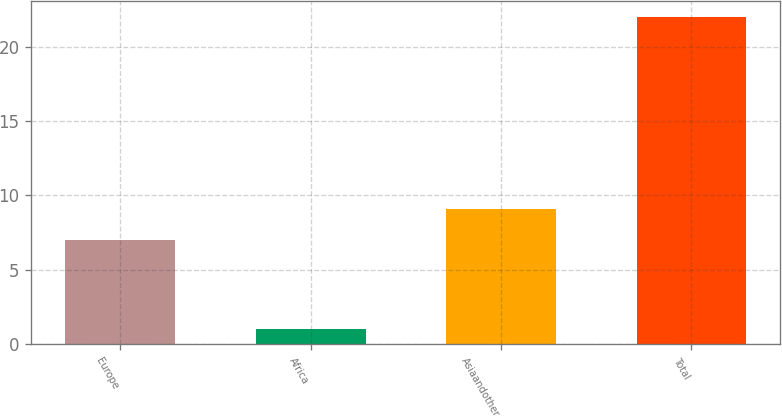<chart> <loc_0><loc_0><loc_500><loc_500><bar_chart><fcel>Europe<fcel>Africa<fcel>Asiaandother<fcel>Total<nl><fcel>7<fcel>1<fcel>9.1<fcel>22<nl></chart> 